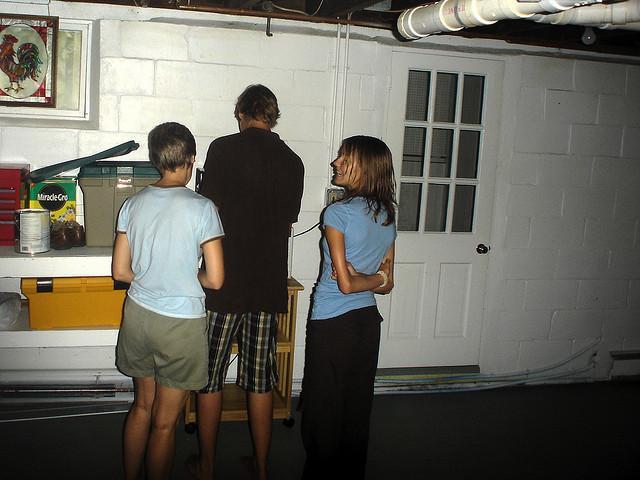How many people are there?
Give a very brief answer. 3. How many people are in the picture?
Give a very brief answer. 3. 